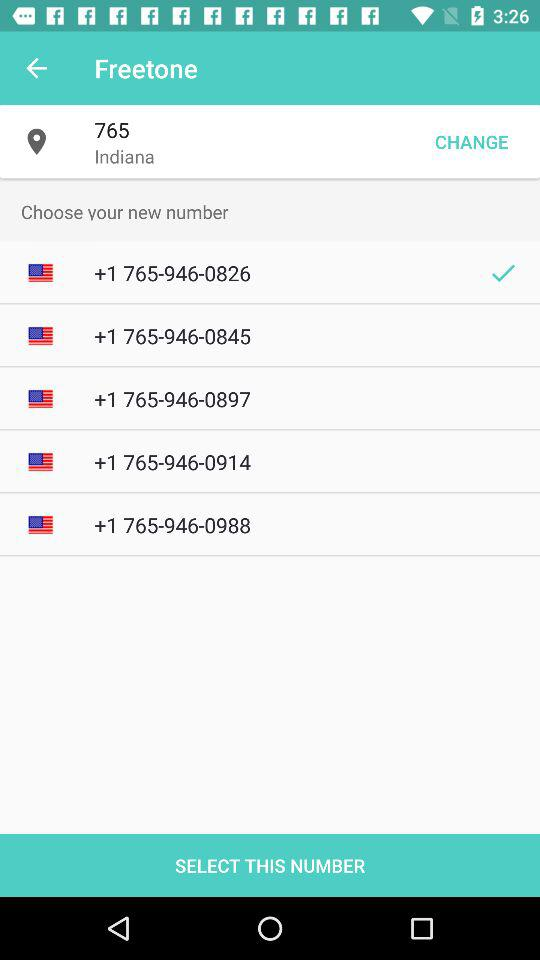How many numbers have a check mark next to them?
Answer the question using a single word or phrase. 1 